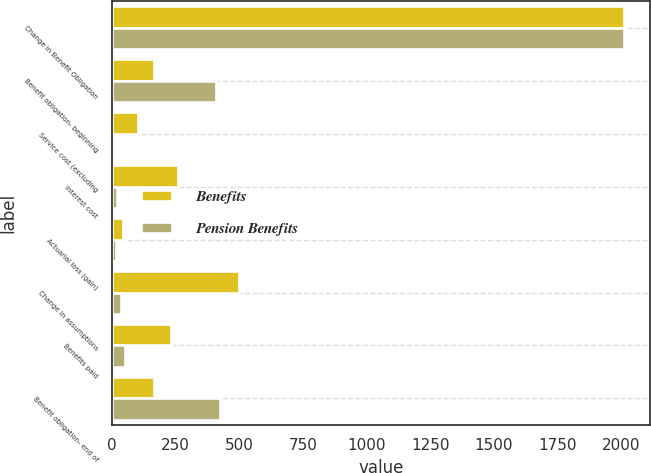<chart> <loc_0><loc_0><loc_500><loc_500><stacked_bar_chart><ecel><fcel>Change in Benefit Obligation<fcel>Benefit obligation- beginning<fcel>Service cost (excluding<fcel>Interest cost<fcel>Actuarial loss (gain)<fcel>Change in assumptions<fcel>Benefits paid<fcel>Benefit obligation- end of<nl><fcel>Benefits<fcel>2011<fcel>166<fcel>102<fcel>259<fcel>43<fcel>497<fcel>230<fcel>166<nl><fcel>Pension Benefits<fcel>2011<fcel>408<fcel>5<fcel>20<fcel>15<fcel>37<fcel>52<fcel>424<nl></chart> 